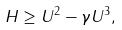Convert formula to latex. <formula><loc_0><loc_0><loc_500><loc_500>H \geq U ^ { 2 } - \gamma U ^ { 3 } ,</formula> 